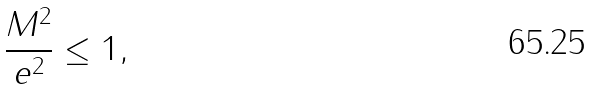Convert formula to latex. <formula><loc_0><loc_0><loc_500><loc_500>\frac { M ^ { 2 } } { e ^ { 2 } } \leq 1 ,</formula> 